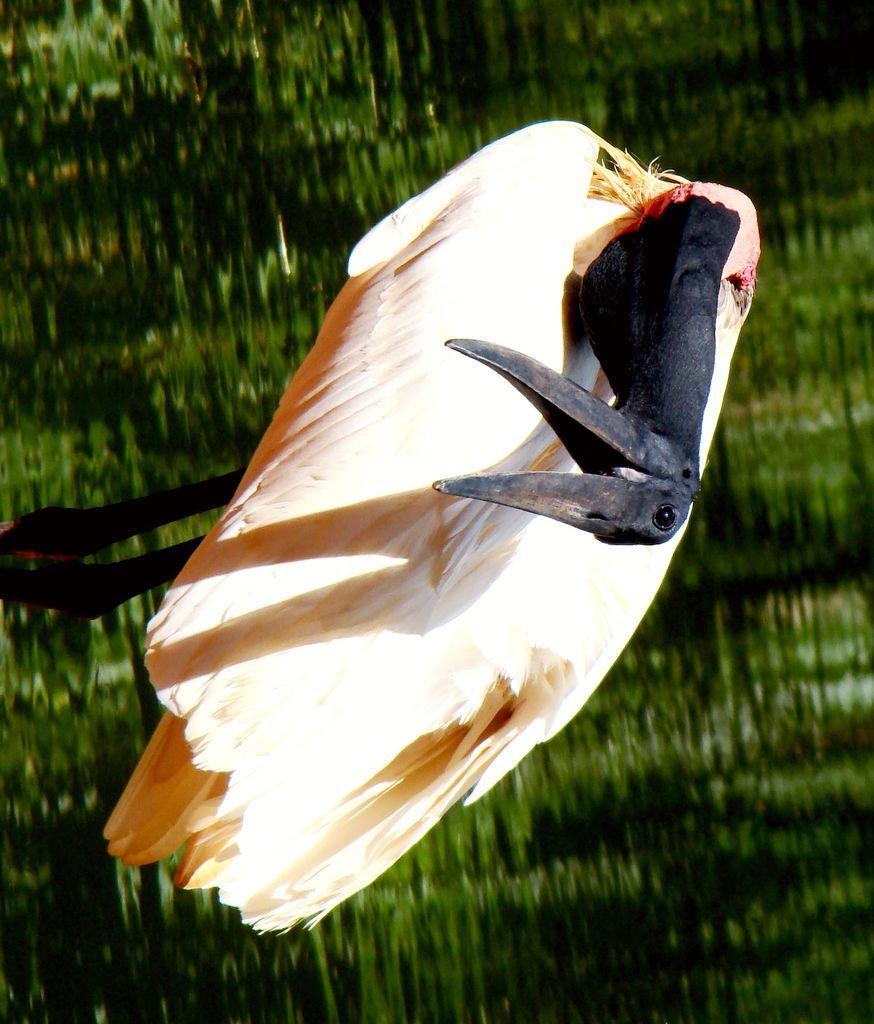Can you describe this image briefly? In this picture we can see a bird on the ground. 